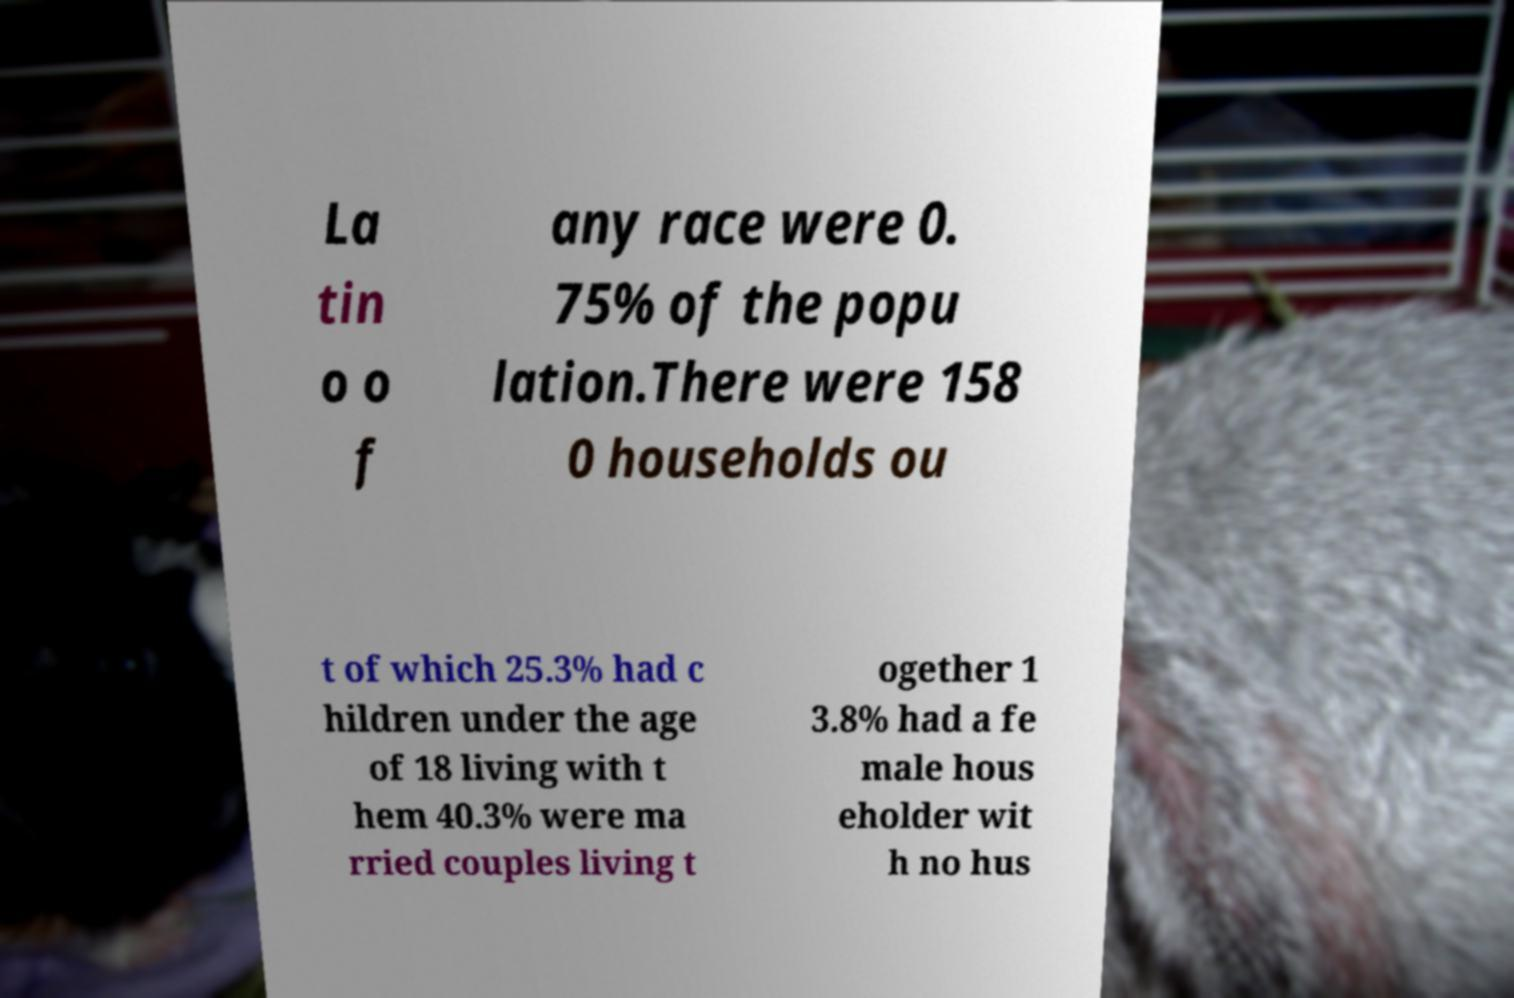There's text embedded in this image that I need extracted. Can you transcribe it verbatim? La tin o o f any race were 0. 75% of the popu lation.There were 158 0 households ou t of which 25.3% had c hildren under the age of 18 living with t hem 40.3% were ma rried couples living t ogether 1 3.8% had a fe male hous eholder wit h no hus 